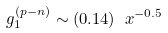<formula> <loc_0><loc_0><loc_500><loc_500>g _ { 1 } ^ { ( p - n ) } \sim ( 0 . 1 4 ) \ x ^ { - 0 . 5 }</formula> 